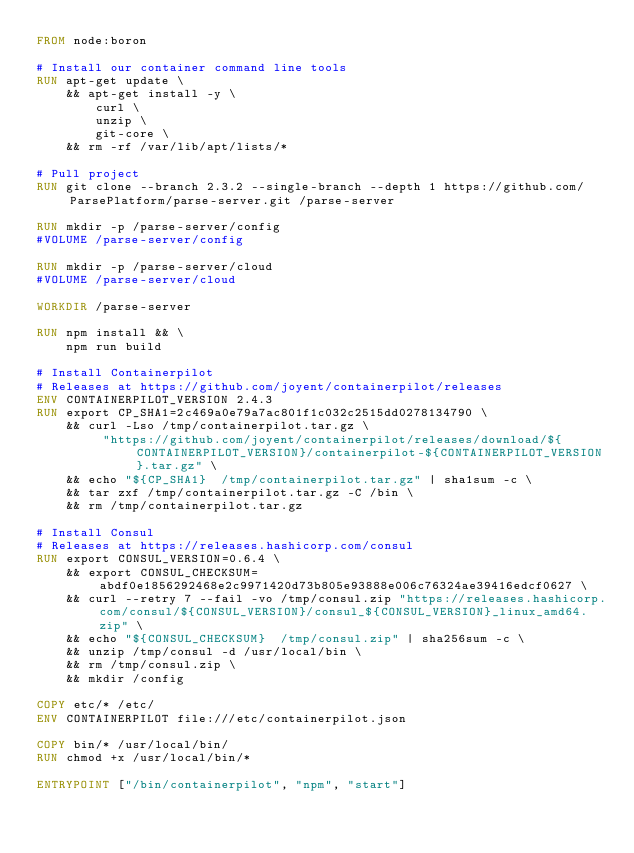<code> <loc_0><loc_0><loc_500><loc_500><_Dockerfile_>FROM node:boron

# Install our container command line tools
RUN apt-get update \
    && apt-get install -y \
        curl \
        unzip \
        git-core \
    && rm -rf /var/lib/apt/lists/*

# Pull project
RUN git clone --branch 2.3.2 --single-branch --depth 1 https://github.com/ParsePlatform/parse-server.git /parse-server

RUN mkdir -p /parse-server/config
#VOLUME /parse-server/config

RUN mkdir -p /parse-server/cloud
#VOLUME /parse-server/cloud

WORKDIR /parse-server

RUN npm install && \
    npm run build

# Install Containerpilot
# Releases at https://github.com/joyent/containerpilot/releases
ENV CONTAINERPILOT_VERSION 2.4.3
RUN export CP_SHA1=2c469a0e79a7ac801f1c032c2515dd0278134790 \
    && curl -Lso /tmp/containerpilot.tar.gz \
         "https://github.com/joyent/containerpilot/releases/download/${CONTAINERPILOT_VERSION}/containerpilot-${CONTAINERPILOT_VERSION}.tar.gz" \
    && echo "${CP_SHA1}  /tmp/containerpilot.tar.gz" | sha1sum -c \
    && tar zxf /tmp/containerpilot.tar.gz -C /bin \
    && rm /tmp/containerpilot.tar.gz

# Install Consul
# Releases at https://releases.hashicorp.com/consul
RUN export CONSUL_VERSION=0.6.4 \
    && export CONSUL_CHECKSUM=abdf0e1856292468e2c9971420d73b805e93888e006c76324ae39416edcf0627 \
    && curl --retry 7 --fail -vo /tmp/consul.zip "https://releases.hashicorp.com/consul/${CONSUL_VERSION}/consul_${CONSUL_VERSION}_linux_amd64.zip" \
    && echo "${CONSUL_CHECKSUM}  /tmp/consul.zip" | sha256sum -c \
    && unzip /tmp/consul -d /usr/local/bin \
    && rm /tmp/consul.zip \
    && mkdir /config

COPY etc/* /etc/
ENV CONTAINERPILOT file:///etc/containerpilot.json

COPY bin/* /usr/local/bin/
RUN chmod +x /usr/local/bin/*

ENTRYPOINT ["/bin/containerpilot", "npm", "start"]
</code> 